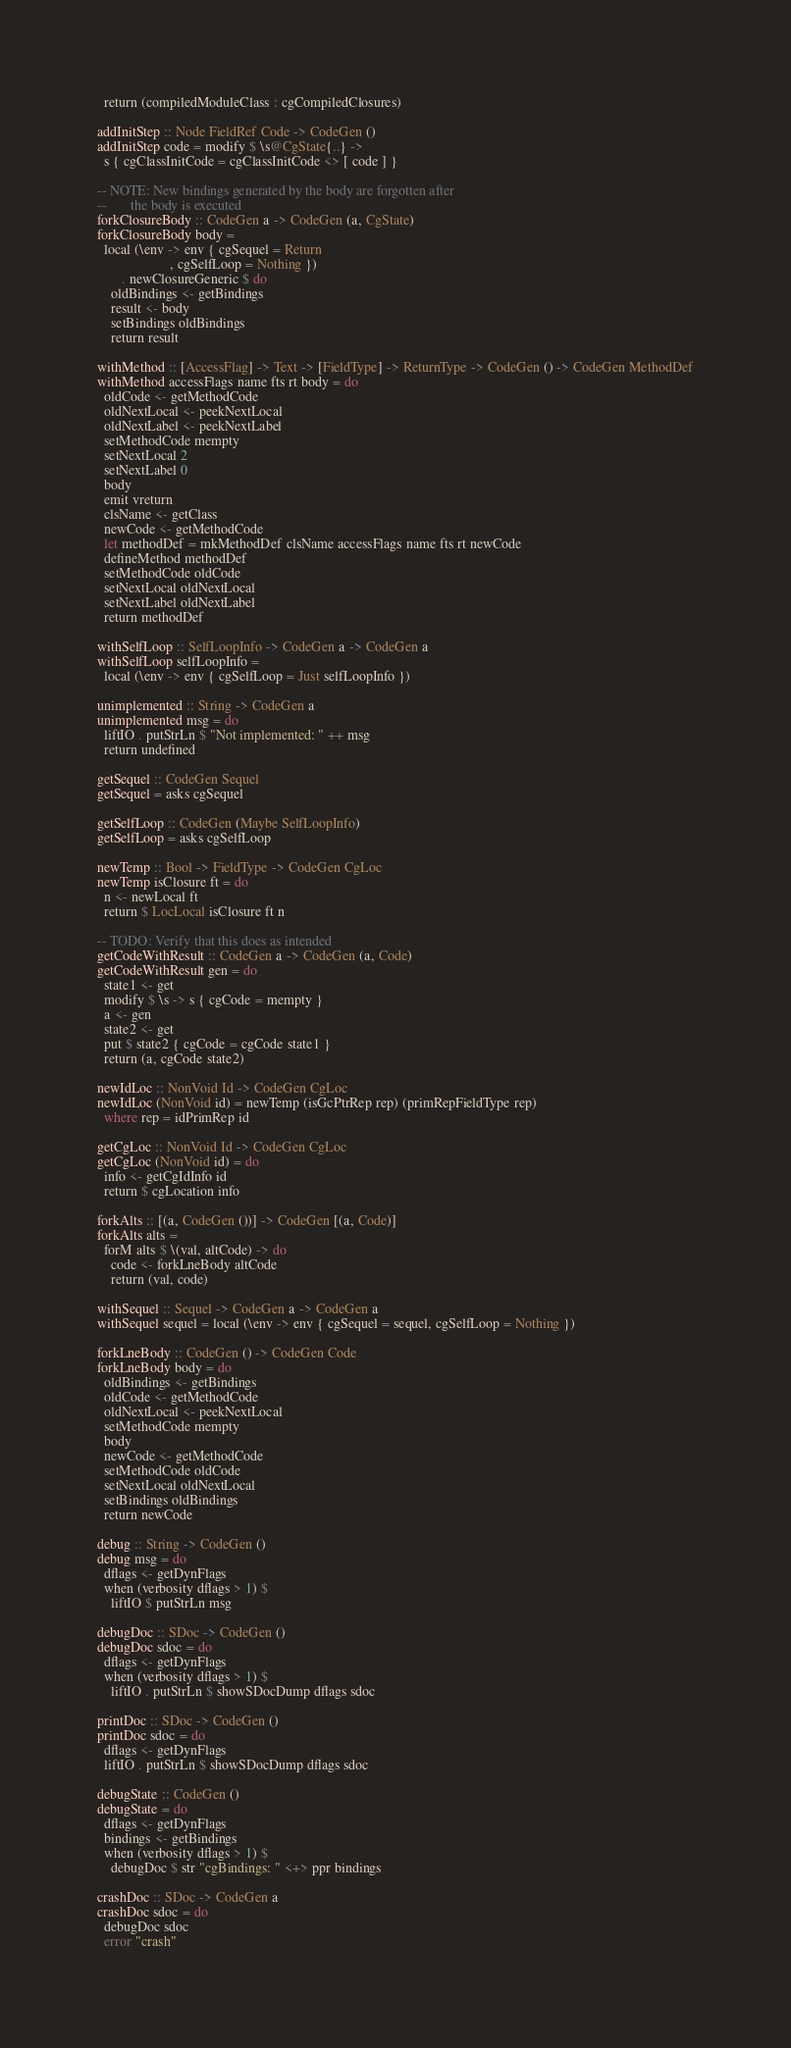<code> <loc_0><loc_0><loc_500><loc_500><_Haskell_>  return (compiledModuleClass : cgCompiledClosures)

addInitStep :: Node FieldRef Code -> CodeGen ()
addInitStep code = modify $ \s@CgState{..} ->
  s { cgClassInitCode = cgClassInitCode <> [ code ] }

-- NOTE: New bindings generated by the body are forgotten after
--       the body is executed
forkClosureBody :: CodeGen a -> CodeGen (a, CgState)
forkClosureBody body =
  local (\env -> env { cgSequel = Return
                     , cgSelfLoop = Nothing })
       . newClosureGeneric $ do
    oldBindings <- getBindings
    result <- body
    setBindings oldBindings
    return result

withMethod :: [AccessFlag] -> Text -> [FieldType] -> ReturnType -> CodeGen () -> CodeGen MethodDef
withMethod accessFlags name fts rt body = do
  oldCode <- getMethodCode
  oldNextLocal <- peekNextLocal
  oldNextLabel <- peekNextLabel
  setMethodCode mempty
  setNextLocal 2
  setNextLabel 0
  body
  emit vreturn
  clsName <- getClass
  newCode <- getMethodCode
  let methodDef = mkMethodDef clsName accessFlags name fts rt newCode
  defineMethod methodDef
  setMethodCode oldCode
  setNextLocal oldNextLocal
  setNextLabel oldNextLabel
  return methodDef

withSelfLoop :: SelfLoopInfo -> CodeGen a -> CodeGen a
withSelfLoop selfLoopInfo =
  local (\env -> env { cgSelfLoop = Just selfLoopInfo })

unimplemented :: String -> CodeGen a
unimplemented msg = do
  liftIO . putStrLn $ "Not implemented: " ++ msg
  return undefined

getSequel :: CodeGen Sequel
getSequel = asks cgSequel

getSelfLoop :: CodeGen (Maybe SelfLoopInfo)
getSelfLoop = asks cgSelfLoop

newTemp :: Bool -> FieldType -> CodeGen CgLoc
newTemp isClosure ft = do
  n <- newLocal ft
  return $ LocLocal isClosure ft n

-- TODO: Verify that this does as intended
getCodeWithResult :: CodeGen a -> CodeGen (a, Code)
getCodeWithResult gen = do
  state1 <- get
  modify $ \s -> s { cgCode = mempty }
  a <- gen
  state2 <- get
  put $ state2 { cgCode = cgCode state1 }
  return (a, cgCode state2)

newIdLoc :: NonVoid Id -> CodeGen CgLoc
newIdLoc (NonVoid id) = newTemp (isGcPtrRep rep) (primRepFieldType rep)
  where rep = idPrimRep id

getCgLoc :: NonVoid Id -> CodeGen CgLoc
getCgLoc (NonVoid id) = do
  info <- getCgIdInfo id
  return $ cgLocation info

forkAlts :: [(a, CodeGen ())] -> CodeGen [(a, Code)]
forkAlts alts =
  forM alts $ \(val, altCode) -> do
    code <- forkLneBody altCode
    return (val, code)

withSequel :: Sequel -> CodeGen a -> CodeGen a
withSequel sequel = local (\env -> env { cgSequel = sequel, cgSelfLoop = Nothing })

forkLneBody :: CodeGen () -> CodeGen Code
forkLneBody body = do
  oldBindings <- getBindings
  oldCode <- getMethodCode
  oldNextLocal <- peekNextLocal
  setMethodCode mempty
  body
  newCode <- getMethodCode
  setMethodCode oldCode
  setNextLocal oldNextLocal
  setBindings oldBindings
  return newCode

debug :: String -> CodeGen ()
debug msg = do
  dflags <- getDynFlags
  when (verbosity dflags > 1) $
    liftIO $ putStrLn msg

debugDoc :: SDoc -> CodeGen ()
debugDoc sdoc = do
  dflags <- getDynFlags
  when (verbosity dflags > 1) $
    liftIO . putStrLn $ showSDocDump dflags sdoc

printDoc :: SDoc -> CodeGen ()
printDoc sdoc = do
  dflags <- getDynFlags
  liftIO . putStrLn $ showSDocDump dflags sdoc

debugState :: CodeGen ()
debugState = do
  dflags <- getDynFlags
  bindings <- getBindings
  when (verbosity dflags > 1) $
    debugDoc $ str "cgBindings: " <+> ppr bindings

crashDoc :: SDoc -> CodeGen a
crashDoc sdoc = do
  debugDoc sdoc
  error "crash"
</code> 